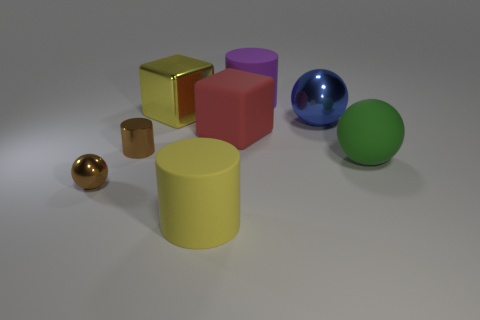What material is the tiny cylinder that is the same color as the small metal sphere?
Your answer should be very brief. Metal. There is a yellow thing that is in front of the large red rubber cube; is there a tiny thing that is right of it?
Ensure brevity in your answer.  No. What number of other things are the same color as the shiny block?
Provide a succinct answer. 1. Does the brown metallic object that is in front of the rubber sphere have the same size as the rubber object behind the large yellow cube?
Offer a very short reply. No. How big is the shiny thing on the right side of the large block behind the rubber cube?
Your answer should be very brief. Large. What is the big thing that is both in front of the large yellow metallic thing and on the left side of the red object made of?
Offer a terse response. Rubber. What color is the large metallic ball?
Your answer should be very brief. Blue. The rubber thing that is on the right side of the purple rubber cylinder has what shape?
Give a very brief answer. Sphere. Are there any things that are to the left of the big shiny thing left of the large purple matte thing that is behind the large yellow cube?
Offer a very short reply. Yes. Are there any small cyan metallic cylinders?
Your response must be concise. No. 